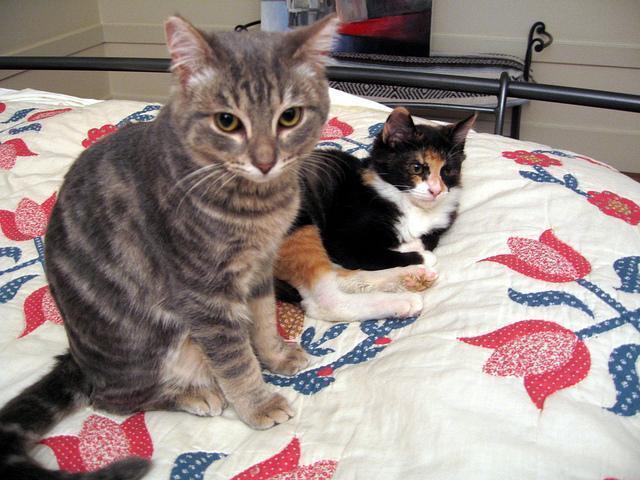What is the difference of these two cats?
Select the accurate response from the four choices given to answer the question.
Options: Species, eyes, animal, breed. Breed. 